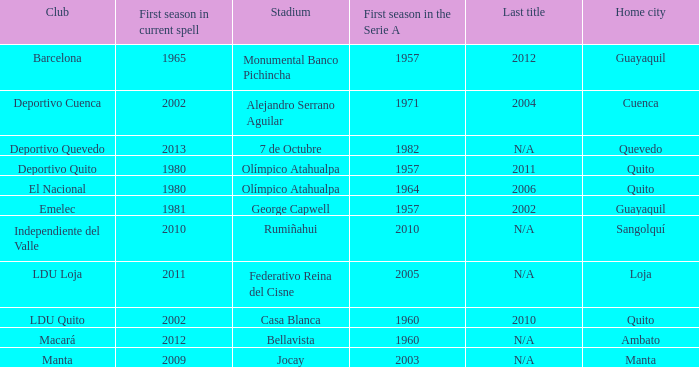Name the last title for 2012 N/A. 